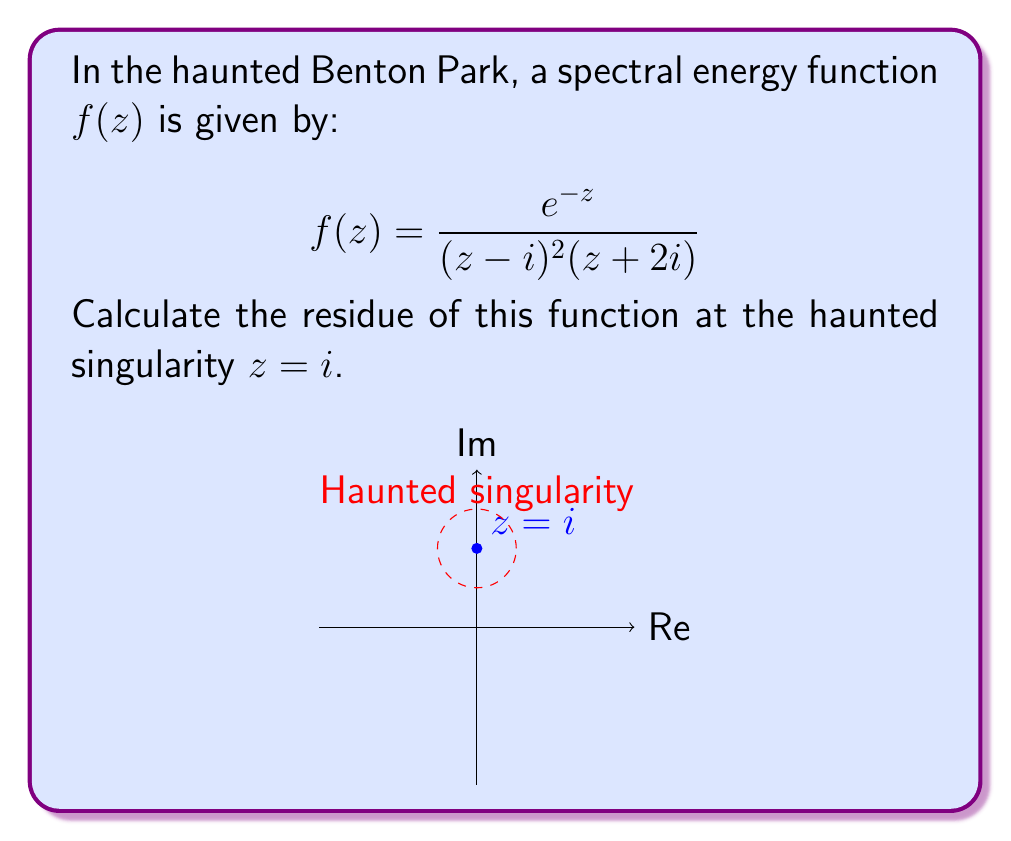Can you answer this question? To calculate the residue at $z=i$, we need to follow these ghostly steps:

1) First, we identify that $z=i$ is a pole of order 2 (double pole).

2) For a pole of order 2, we use the formula:

   $$\text{Res}(f,i) = \lim_{z \to i} \frac{d}{dz}\left[(z-i)^2f(z)\right]$$

3) Let's define $g(z) = (z-i)^2f(z)$:

   $$g(z) = (z-i)^2 \cdot \frac{e^{-z}}{(z-i)^2(z+2i)} = \frac{e^{-z}}{z+2i}$$

4) Now we need to differentiate $g(z)$:

   $$g'(z) = \frac{-e^{-z}(z+2i) - e^{-z}}{(z+2i)^2} = -\frac{e^{-z}(z+2i+1)}{(z+2i)^2}$$

5) Finally, we evaluate this at $z=i$:

   $$\text{Res}(f,i) = g'(i) = -\frac{e^{-i}(i+2i+1)}{(i+2i)^2} = -\frac{e^{-i}(3i+1)}{9i^2} = \frac{e^{-i}(3i+1)}{9}$$

6) Simplifying:

   $$\frac{e^{-i}(3i+1)}{9} = \frac{e^{-i}}{9}(3i+1) = \frac{e^{-i}}{9}(1+3i)$$

   $$= \frac{(\cos 1 - i\sin 1)(1+3i)}{9} = \frac{\cos 1 + 3i\cos 1 - i\sin 1 + 3\sin 1}{9}$$

   $$= \frac{(\cos 1 + 3\sin 1) + i(3\cos 1 - \sin 1)}{9}$$
Answer: $\frac{(\cos 1 + 3\sin 1) + i(3\cos 1 - \sin 1)}{9}$ 